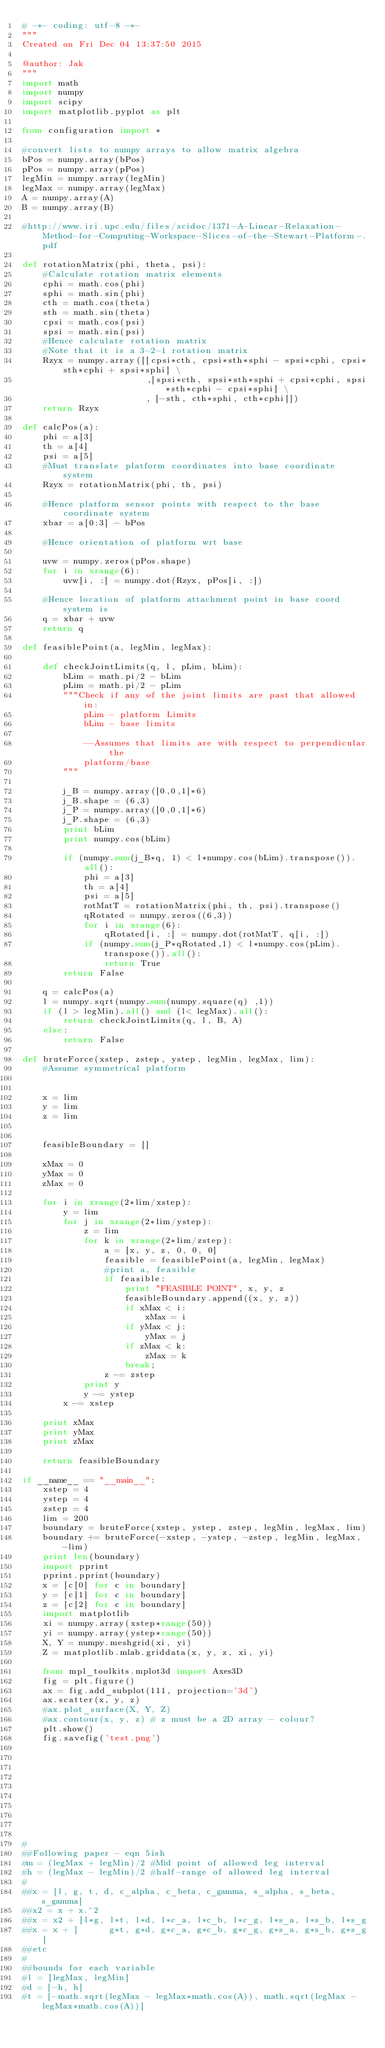<code> <loc_0><loc_0><loc_500><loc_500><_Python_># -*- coding: utf-8 -*-
"""
Created on Fri Dec 04 13:37:50 2015

@author: Jak
"""
import math
import numpy
import scipy
import matplotlib.pyplot as plt

from configuration import *

#convert lists to numpy arrays to allow matrix algebra
bPos = numpy.array(bPos)
pPos = numpy.array(pPos)
legMin = numpy.array(legMin)
legMax = numpy.array(legMax)
A = numpy.array(A)
B = numpy.array(B)

#http://www.iri.upc.edu/files/scidoc/1371-A-Linear-Relaxation-Method-for-Computing-Workspace-Slices-of-the-Stewart-Platform-.pdf

def rotationMatrix(phi, theta, psi):
    #Calculate rotation matrix elements
    cphi = math.cos(phi)
    sphi = math.sin(phi)
    cth = math.cos(theta)
    sth = math.sin(theta)
    cpsi = math.cos(psi)
    spsi = math.sin(psi)  
    #Hence calculate rotation matrix
    #Note that it is a 3-2-1 rotation matrix
    Rzyx = numpy.array([[cpsi*cth, cpsi*sth*sphi - spsi*cphi, cpsi*sth*cphi + spsi*sphi] \
                        ,[spsi*cth, spsi*sth*sphi + cpsi*cphi, spsi*sth*cphi - cpsi*sphi] \
                        , [-sth, cth*sphi, cth*cphi]])
    return Rzyx
    
def calcPos(a):  
    phi = a[3]
    th = a[4]
    psi = a[5]
    #Must translate platform coordinates into base coordinate system
    Rzyx = rotationMatrix(phi, th, psi)
                        
    #Hence platform sensor points with respect to the base coordinate system
    xbar = a[0:3] - bPos
    
    #Hence orientation of platform wrt base
    
    uvw = numpy.zeros(pPos.shape)
    for i in xrange(6):
        uvw[i, :] = numpy.dot(Rzyx, pPos[i, :])
        
    #Hence location of platform attachment point in base coord system is
    q = xbar + uvw
    return q
    
def feasiblePoint(a, legMin, legMax):
    
    def checkJointLimits(q, l, pLim, bLim):
        bLim = math.pi/2 - bLim
        pLim = math.pi/2 - pLim
        """Check if any of the joint limits are past that allowed in:
            pLim - platform Limits
            bLim - base limits
            
            --Assumes that limits are with respect to perpendicular the
            platform/base
        """
        
        j_B = numpy.array([0,0,1]*6)
        j_B.shape = (6,3)
        j_P = numpy.array([0,0,1]*6)
        j_P.shape = (6,3)
        print bLim
        print numpy.cos(bLim)

        if (numpy.sum(j_B*q, 1) < l*numpy.cos(bLim).transpose()).all():
            phi = a[3]
            th = a[4]
            psi = a[5]
            rotMatT = rotationMatrix(phi, th, psi).transpose()
            qRotated = numpy.zeros((6,3))
            for i in xrange(6):
                qRotated[i, :] = numpy.dot(rotMatT, q[i, :])
            if (numpy.sum(j_P*qRotated,1) < l*numpy.cos(pLim).transpose()).all():
                return True
        return False
            
    q = calcPos(a)
    l = numpy.sqrt(numpy.sum(numpy.square(q) ,1))
    if (l > legMin).all() and (l< legMax).all():
        return checkJointLimits(q, l, B, A)
    else:
        return False

def bruteForce(xstep, zstep, ystep, legMin, legMax, lim):
    #Assume symmetrical platform

    
    x = lim
    y = lim
    z = lim

        
    feasibleBoundary = []
    
    xMax = 0
    yMax = 0
    zMax = 0
    
    for i in xrange(2*lim/xstep):
        y = lim
        for j in xrange(2*lim/ystep):
            z = lim
            for k in xrange(2*lim/zstep):
                a = [x, y, z, 0, 0, 0]
                feasible = feasiblePoint(a, legMin, legMax)
                #print a, feasible
                if feasible:
                    print "FEASIBLE POINT", x, y, z
                    feasibleBoundary.append((x, y, z))
                    if xMax < i:
                        xMax = i
                    if yMax < j:
                        yMax = j
                    if zMax < k:
                        zMax = k             
                    break;
                z -= zstep
            print y
            y -= ystep
        x -= xstep
        
    print xMax
    print yMax
    print zMax
        
    return feasibleBoundary
    
if __name__ == "__main__":
    xstep = 4
    ystep = 4
    zstep = 4
    lim = 200
    boundary = bruteForce(xstep, ystep, zstep, legMin, legMax, lim)
    boundary += bruteForce(-xstep, -ystep, -zstep, legMin, legMax, -lim)
    print len(boundary)
    import pprint
    pprint.pprint(boundary)
    x = [c[0] for c in boundary]
    y = [c[1] for c in boundary]
    z = [c[2] for c in boundary]
    import matplotlib
    xi = numpy.array(xstep*range(50))
    yi = numpy.array(ystep*range(50))
    X, Y = numpy.meshgrid(xi, yi)
    Z = matplotlib.mlab.griddata(x, y, z, xi, yi)
    
    from mpl_toolkits.mplot3d import Axes3D
    fig = plt.figure()
    ax = fig.add_subplot(111, projection='3d')
    ax.scatter(x, y, z)
    #ax.plot_surface(X, Y, Z)
    #ax.contour(x, y, z) # z must be a 2D array - colour?
    plt.show()
    fig.savefig('test.png')
    
    








#
##Following paper - eqn 5ish
#m = (legMax + legMin)/2 #Mid point of allowed leg interval
#h = (legMax - legMin)/2 #half-range of allowed leg interval
#
##x = [l, g, t, d, c_alpha, c_beta, c_gamma, s_alpha, s_beta, s_gamma]
##x2 = x + x.^2
##x = x2 + [l*g, l*t, l*d, l*c_a, l*c_b, l*c_g, l*s_a, l*s_b, l*s_g
##x = x + [      g*t, g*d, g*c_a, g*c_b, g*c_g, g*s_a, g*s_b, g*s_g]
##etc
#
##bounds for each variable
#l = [legMax, legMin]
#d = [-h, h]
#t = [-math.sqrt(legMax - legMax*math.cos(A)), math.sqrt(legMax - legMax*math.cos(A))] </code> 